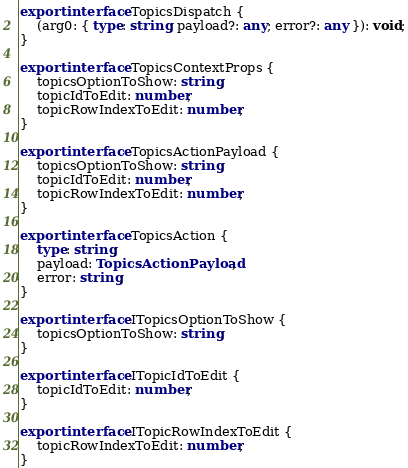<code> <loc_0><loc_0><loc_500><loc_500><_TypeScript_>export interface TopicsDispatch {
	(arg0: { type: string; payload?: any; error?: any }): void;
}

export interface TopicsContextProps {
	topicsOptionToShow: string;
	topicIdToEdit: number;
	topicRowIndexToEdit: number;
}

export interface TopicsActionPayload {
	topicsOptionToShow: string;
	topicIdToEdit: number;
	topicRowIndexToEdit: number;
}

export interface TopicsAction {
	type: string;
	payload: TopicsActionPayload;
	error: string;
}

export interface ITopicsOptionToShow {
	topicsOptionToShow: string;
}

export interface ITopicIdToEdit {
	topicIdToEdit: number;
}

export interface ITopicRowIndexToEdit {
	topicRowIndexToEdit: number;
}</code> 